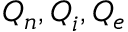Convert formula to latex. <formula><loc_0><loc_0><loc_500><loc_500>Q _ { n } , Q _ { i } , Q _ { e }</formula> 